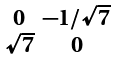Convert formula to latex. <formula><loc_0><loc_0><loc_500><loc_500>\begin{smallmatrix} 0 & - 1 / \sqrt { 7 } \\ \sqrt { 7 } & 0 \end{smallmatrix}</formula> 